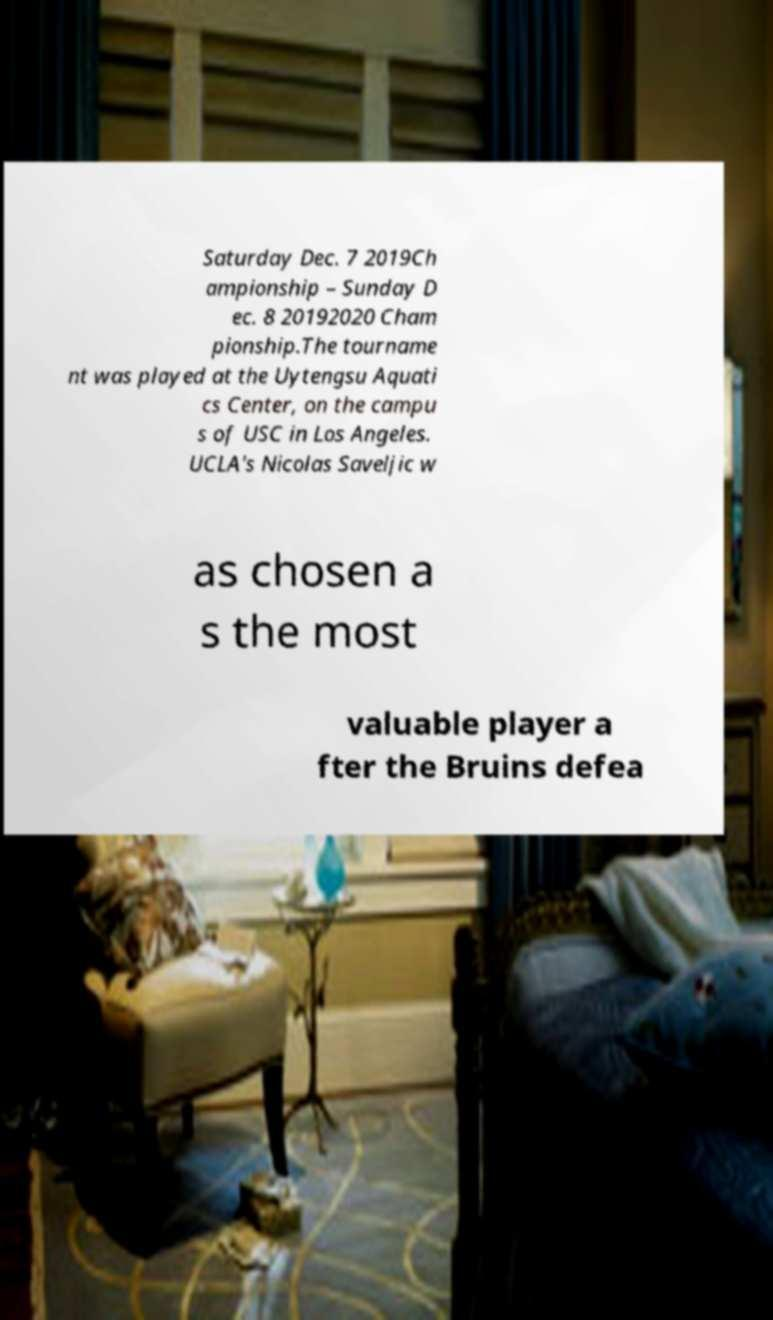Could you extract and type out the text from this image? Saturday Dec. 7 2019Ch ampionship – Sunday D ec. 8 20192020 Cham pionship.The tourname nt was played at the Uytengsu Aquati cs Center, on the campu s of USC in Los Angeles. UCLA's Nicolas Saveljic w as chosen a s the most valuable player a fter the Bruins defea 